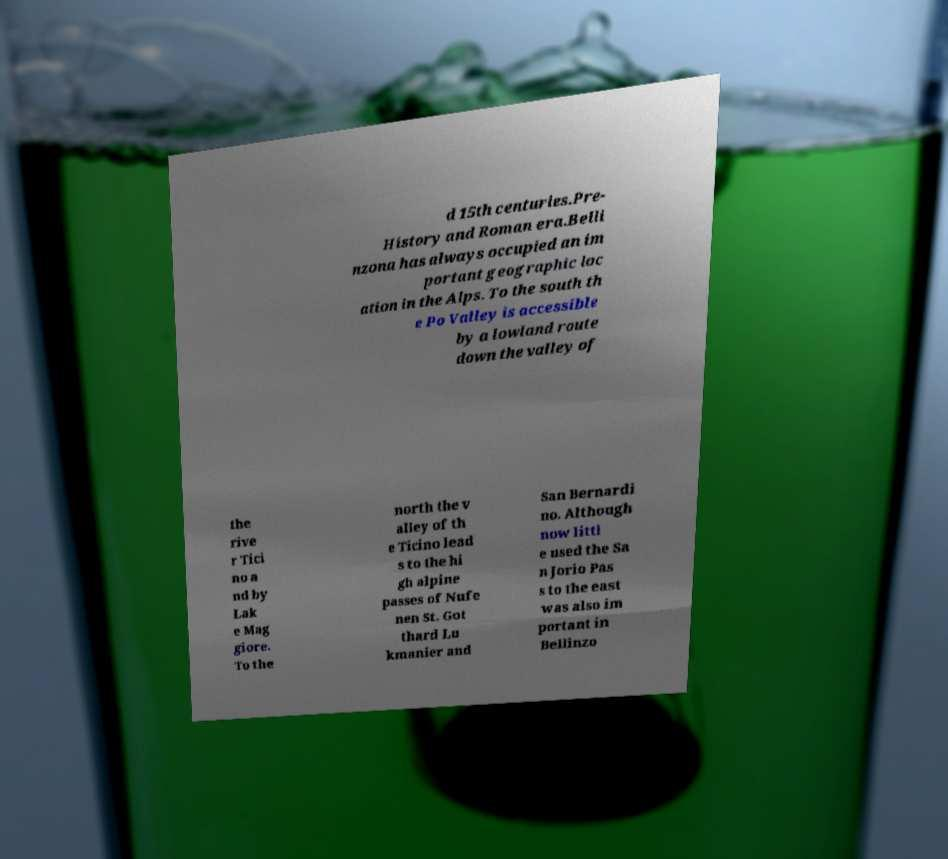What messages or text are displayed in this image? I need them in a readable, typed format. d 15th centuries.Pre- History and Roman era.Belli nzona has always occupied an im portant geographic loc ation in the Alps. To the south th e Po Valley is accessible by a lowland route down the valley of the rive r Tici no a nd by Lak e Mag giore. To the north the v alley of th e Ticino lead s to the hi gh alpine passes of Nufe nen St. Got thard Lu kmanier and San Bernardi no. Although now littl e used the Sa n Jorio Pas s to the east was also im portant in Bellinzo 